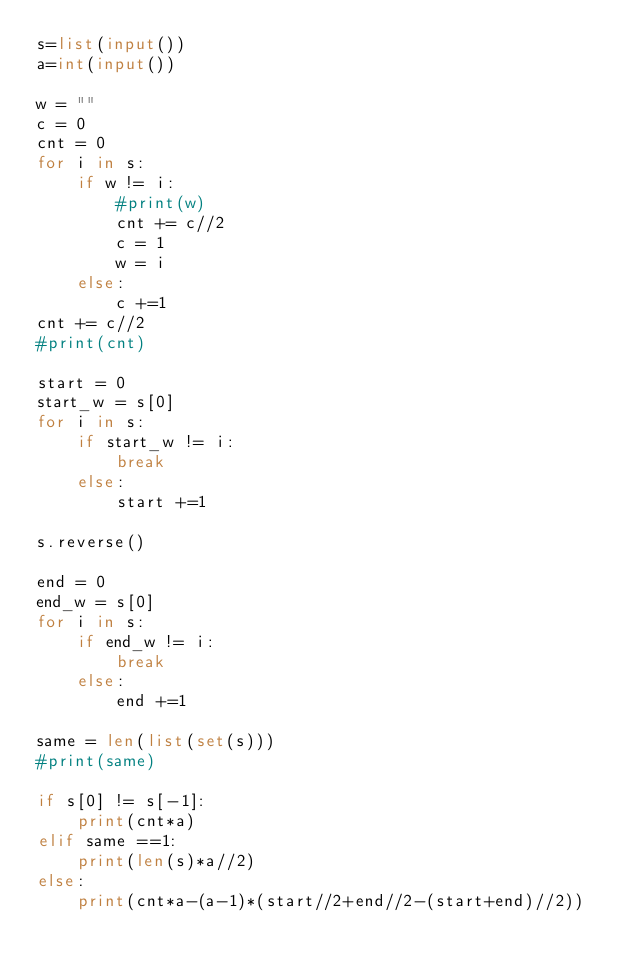Convert code to text. <code><loc_0><loc_0><loc_500><loc_500><_Python_>s=list(input())
a=int(input())

w = ""
c = 0
cnt = 0
for i in s:
    if w != i:
        #print(w)
        cnt += c//2
        c = 1
        w = i
    else:
        c +=1
cnt += c//2
#print(cnt)

start = 0
start_w = s[0]
for i in s:
    if start_w != i:
        break
    else:
        start +=1

s.reverse()

end = 0
end_w = s[0]
for i in s:
    if end_w != i:
        break
    else:
        end +=1

same = len(list(set(s)))
#print(same)

if s[0] != s[-1]:
    print(cnt*a)
elif same ==1:
    print(len(s)*a//2)
else:
    print(cnt*a-(a-1)*(start//2+end//2-(start+end)//2))</code> 